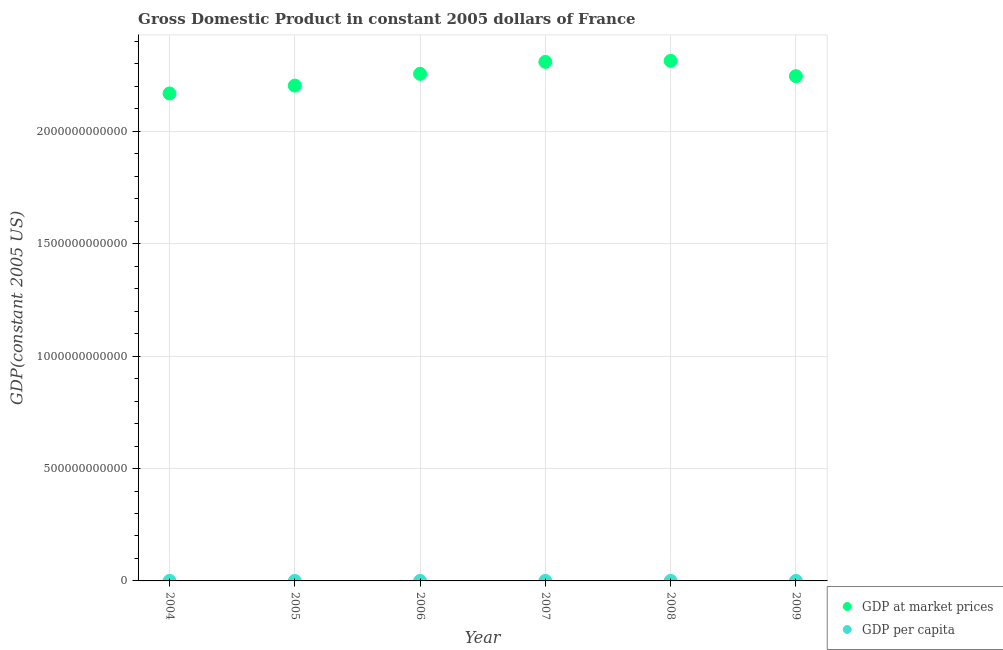What is the gdp per capita in 2008?
Your answer should be very brief. 3.59e+04. Across all years, what is the maximum gdp per capita?
Provide a short and direct response. 3.61e+04. Across all years, what is the minimum gdp per capita?
Provide a short and direct response. 3.46e+04. In which year was the gdp per capita minimum?
Your answer should be compact. 2004. What is the total gdp per capita in the graph?
Offer a terse response. 2.12e+05. What is the difference between the gdp per capita in 2007 and that in 2008?
Your answer should be very brief. 130.98. What is the difference between the gdp per capita in 2007 and the gdp at market prices in 2008?
Give a very brief answer. -2.31e+12. What is the average gdp at market prices per year?
Keep it short and to the point. 2.25e+12. In the year 2007, what is the difference between the gdp at market prices and gdp per capita?
Provide a succinct answer. 2.31e+12. What is the ratio of the gdp at market prices in 2004 to that in 2005?
Offer a terse response. 0.98. Is the difference between the gdp per capita in 2005 and 2009 greater than the difference between the gdp at market prices in 2005 and 2009?
Provide a succinct answer. Yes. What is the difference between the highest and the second highest gdp at market prices?
Offer a very short reply. 4.51e+09. What is the difference between the highest and the lowest gdp at market prices?
Make the answer very short. 1.45e+11. In how many years, is the gdp per capita greater than the average gdp per capita taken over all years?
Give a very brief answer. 3. How many years are there in the graph?
Your response must be concise. 6. What is the difference between two consecutive major ticks on the Y-axis?
Your response must be concise. 5.00e+11. Are the values on the major ticks of Y-axis written in scientific E-notation?
Make the answer very short. No. Does the graph contain grids?
Give a very brief answer. Yes. Where does the legend appear in the graph?
Your answer should be compact. Bottom right. How many legend labels are there?
Give a very brief answer. 2. How are the legend labels stacked?
Your response must be concise. Vertical. What is the title of the graph?
Ensure brevity in your answer.  Gross Domestic Product in constant 2005 dollars of France. What is the label or title of the Y-axis?
Offer a very short reply. GDP(constant 2005 US). What is the GDP(constant 2005 US) in GDP at market prices in 2004?
Give a very brief answer. 2.17e+12. What is the GDP(constant 2005 US) of GDP per capita in 2004?
Your response must be concise. 3.46e+04. What is the GDP(constant 2005 US) in GDP at market prices in 2005?
Offer a very short reply. 2.20e+12. What is the GDP(constant 2005 US) of GDP per capita in 2005?
Your answer should be very brief. 3.49e+04. What is the GDP(constant 2005 US) of GDP at market prices in 2006?
Your answer should be compact. 2.26e+12. What is the GDP(constant 2005 US) in GDP per capita in 2006?
Your answer should be compact. 3.55e+04. What is the GDP(constant 2005 US) of GDP at market prices in 2007?
Provide a succinct answer. 2.31e+12. What is the GDP(constant 2005 US) in GDP per capita in 2007?
Give a very brief answer. 3.61e+04. What is the GDP(constant 2005 US) in GDP at market prices in 2008?
Offer a very short reply. 2.31e+12. What is the GDP(constant 2005 US) of GDP per capita in 2008?
Ensure brevity in your answer.  3.59e+04. What is the GDP(constant 2005 US) of GDP at market prices in 2009?
Your answer should be compact. 2.25e+12. What is the GDP(constant 2005 US) in GDP per capita in 2009?
Make the answer very short. 3.47e+04. Across all years, what is the maximum GDP(constant 2005 US) in GDP at market prices?
Your answer should be very brief. 2.31e+12. Across all years, what is the maximum GDP(constant 2005 US) in GDP per capita?
Provide a short and direct response. 3.61e+04. Across all years, what is the minimum GDP(constant 2005 US) in GDP at market prices?
Make the answer very short. 2.17e+12. Across all years, what is the minimum GDP(constant 2005 US) in GDP per capita?
Ensure brevity in your answer.  3.46e+04. What is the total GDP(constant 2005 US) of GDP at market prices in the graph?
Give a very brief answer. 1.35e+13. What is the total GDP(constant 2005 US) of GDP per capita in the graph?
Keep it short and to the point. 2.12e+05. What is the difference between the GDP(constant 2005 US) of GDP at market prices in 2004 and that in 2005?
Your response must be concise. -3.49e+1. What is the difference between the GDP(constant 2005 US) of GDP per capita in 2004 and that in 2005?
Your answer should be compact. -292.15. What is the difference between the GDP(constant 2005 US) in GDP at market prices in 2004 and that in 2006?
Keep it short and to the point. -8.72e+1. What is the difference between the GDP(constant 2005 US) of GDP per capita in 2004 and that in 2006?
Your answer should be compact. -872.44. What is the difference between the GDP(constant 2005 US) of GDP at market prices in 2004 and that in 2007?
Provide a short and direct response. -1.40e+11. What is the difference between the GDP(constant 2005 US) of GDP per capita in 2004 and that in 2007?
Keep it short and to the point. -1485.94. What is the difference between the GDP(constant 2005 US) of GDP at market prices in 2004 and that in 2008?
Give a very brief answer. -1.45e+11. What is the difference between the GDP(constant 2005 US) of GDP per capita in 2004 and that in 2008?
Make the answer very short. -1354.96. What is the difference between the GDP(constant 2005 US) in GDP at market prices in 2004 and that in 2009?
Your answer should be very brief. -7.69e+1. What is the difference between the GDP(constant 2005 US) of GDP per capita in 2004 and that in 2009?
Offer a terse response. -118.75. What is the difference between the GDP(constant 2005 US) in GDP at market prices in 2005 and that in 2006?
Keep it short and to the point. -5.23e+1. What is the difference between the GDP(constant 2005 US) of GDP per capita in 2005 and that in 2006?
Your answer should be very brief. -580.29. What is the difference between the GDP(constant 2005 US) in GDP at market prices in 2005 and that in 2007?
Your answer should be very brief. -1.06e+11. What is the difference between the GDP(constant 2005 US) in GDP per capita in 2005 and that in 2007?
Provide a succinct answer. -1193.79. What is the difference between the GDP(constant 2005 US) of GDP at market prices in 2005 and that in 2008?
Provide a succinct answer. -1.10e+11. What is the difference between the GDP(constant 2005 US) in GDP per capita in 2005 and that in 2008?
Keep it short and to the point. -1062.81. What is the difference between the GDP(constant 2005 US) in GDP at market prices in 2005 and that in 2009?
Your answer should be very brief. -4.21e+1. What is the difference between the GDP(constant 2005 US) of GDP per capita in 2005 and that in 2009?
Provide a short and direct response. 173.4. What is the difference between the GDP(constant 2005 US) of GDP at market prices in 2006 and that in 2007?
Your answer should be compact. -5.33e+1. What is the difference between the GDP(constant 2005 US) of GDP per capita in 2006 and that in 2007?
Your response must be concise. -613.5. What is the difference between the GDP(constant 2005 US) in GDP at market prices in 2006 and that in 2008?
Give a very brief answer. -5.78e+1. What is the difference between the GDP(constant 2005 US) of GDP per capita in 2006 and that in 2008?
Your answer should be compact. -482.52. What is the difference between the GDP(constant 2005 US) in GDP at market prices in 2006 and that in 2009?
Offer a very short reply. 1.03e+1. What is the difference between the GDP(constant 2005 US) in GDP per capita in 2006 and that in 2009?
Offer a very short reply. 753.69. What is the difference between the GDP(constant 2005 US) of GDP at market prices in 2007 and that in 2008?
Offer a terse response. -4.51e+09. What is the difference between the GDP(constant 2005 US) in GDP per capita in 2007 and that in 2008?
Keep it short and to the point. 130.98. What is the difference between the GDP(constant 2005 US) of GDP at market prices in 2007 and that in 2009?
Keep it short and to the point. 6.35e+1. What is the difference between the GDP(constant 2005 US) in GDP per capita in 2007 and that in 2009?
Your answer should be very brief. 1367.19. What is the difference between the GDP(constant 2005 US) of GDP at market prices in 2008 and that in 2009?
Your response must be concise. 6.81e+1. What is the difference between the GDP(constant 2005 US) in GDP per capita in 2008 and that in 2009?
Give a very brief answer. 1236.21. What is the difference between the GDP(constant 2005 US) in GDP at market prices in 2004 and the GDP(constant 2005 US) in GDP per capita in 2005?
Your answer should be compact. 2.17e+12. What is the difference between the GDP(constant 2005 US) of GDP at market prices in 2004 and the GDP(constant 2005 US) of GDP per capita in 2006?
Your answer should be compact. 2.17e+12. What is the difference between the GDP(constant 2005 US) of GDP at market prices in 2004 and the GDP(constant 2005 US) of GDP per capita in 2007?
Your response must be concise. 2.17e+12. What is the difference between the GDP(constant 2005 US) of GDP at market prices in 2004 and the GDP(constant 2005 US) of GDP per capita in 2008?
Make the answer very short. 2.17e+12. What is the difference between the GDP(constant 2005 US) in GDP at market prices in 2004 and the GDP(constant 2005 US) in GDP per capita in 2009?
Give a very brief answer. 2.17e+12. What is the difference between the GDP(constant 2005 US) of GDP at market prices in 2005 and the GDP(constant 2005 US) of GDP per capita in 2006?
Keep it short and to the point. 2.20e+12. What is the difference between the GDP(constant 2005 US) of GDP at market prices in 2005 and the GDP(constant 2005 US) of GDP per capita in 2007?
Your response must be concise. 2.20e+12. What is the difference between the GDP(constant 2005 US) in GDP at market prices in 2005 and the GDP(constant 2005 US) in GDP per capita in 2008?
Keep it short and to the point. 2.20e+12. What is the difference between the GDP(constant 2005 US) in GDP at market prices in 2005 and the GDP(constant 2005 US) in GDP per capita in 2009?
Keep it short and to the point. 2.20e+12. What is the difference between the GDP(constant 2005 US) in GDP at market prices in 2006 and the GDP(constant 2005 US) in GDP per capita in 2007?
Your response must be concise. 2.26e+12. What is the difference between the GDP(constant 2005 US) of GDP at market prices in 2006 and the GDP(constant 2005 US) of GDP per capita in 2008?
Keep it short and to the point. 2.26e+12. What is the difference between the GDP(constant 2005 US) of GDP at market prices in 2006 and the GDP(constant 2005 US) of GDP per capita in 2009?
Your response must be concise. 2.26e+12. What is the difference between the GDP(constant 2005 US) in GDP at market prices in 2007 and the GDP(constant 2005 US) in GDP per capita in 2008?
Your answer should be very brief. 2.31e+12. What is the difference between the GDP(constant 2005 US) in GDP at market prices in 2007 and the GDP(constant 2005 US) in GDP per capita in 2009?
Make the answer very short. 2.31e+12. What is the difference between the GDP(constant 2005 US) in GDP at market prices in 2008 and the GDP(constant 2005 US) in GDP per capita in 2009?
Ensure brevity in your answer.  2.31e+12. What is the average GDP(constant 2005 US) of GDP at market prices per year?
Your answer should be very brief. 2.25e+12. What is the average GDP(constant 2005 US) in GDP per capita per year?
Your response must be concise. 3.53e+04. In the year 2004, what is the difference between the GDP(constant 2005 US) in GDP at market prices and GDP(constant 2005 US) in GDP per capita?
Your response must be concise. 2.17e+12. In the year 2005, what is the difference between the GDP(constant 2005 US) of GDP at market prices and GDP(constant 2005 US) of GDP per capita?
Provide a succinct answer. 2.20e+12. In the year 2006, what is the difference between the GDP(constant 2005 US) of GDP at market prices and GDP(constant 2005 US) of GDP per capita?
Keep it short and to the point. 2.26e+12. In the year 2007, what is the difference between the GDP(constant 2005 US) of GDP at market prices and GDP(constant 2005 US) of GDP per capita?
Provide a short and direct response. 2.31e+12. In the year 2008, what is the difference between the GDP(constant 2005 US) in GDP at market prices and GDP(constant 2005 US) in GDP per capita?
Provide a succinct answer. 2.31e+12. In the year 2009, what is the difference between the GDP(constant 2005 US) of GDP at market prices and GDP(constant 2005 US) of GDP per capita?
Provide a succinct answer. 2.25e+12. What is the ratio of the GDP(constant 2005 US) in GDP at market prices in 2004 to that in 2005?
Offer a very short reply. 0.98. What is the ratio of the GDP(constant 2005 US) of GDP at market prices in 2004 to that in 2006?
Your answer should be compact. 0.96. What is the ratio of the GDP(constant 2005 US) of GDP per capita in 2004 to that in 2006?
Offer a terse response. 0.98. What is the ratio of the GDP(constant 2005 US) in GDP at market prices in 2004 to that in 2007?
Offer a very short reply. 0.94. What is the ratio of the GDP(constant 2005 US) of GDP per capita in 2004 to that in 2007?
Offer a terse response. 0.96. What is the ratio of the GDP(constant 2005 US) in GDP at market prices in 2004 to that in 2008?
Provide a short and direct response. 0.94. What is the ratio of the GDP(constant 2005 US) of GDP per capita in 2004 to that in 2008?
Keep it short and to the point. 0.96. What is the ratio of the GDP(constant 2005 US) of GDP at market prices in 2004 to that in 2009?
Give a very brief answer. 0.97. What is the ratio of the GDP(constant 2005 US) of GDP per capita in 2004 to that in 2009?
Offer a very short reply. 1. What is the ratio of the GDP(constant 2005 US) in GDP at market prices in 2005 to that in 2006?
Your answer should be compact. 0.98. What is the ratio of the GDP(constant 2005 US) in GDP per capita in 2005 to that in 2006?
Provide a short and direct response. 0.98. What is the ratio of the GDP(constant 2005 US) in GDP at market prices in 2005 to that in 2007?
Keep it short and to the point. 0.95. What is the ratio of the GDP(constant 2005 US) in GDP per capita in 2005 to that in 2007?
Your answer should be very brief. 0.97. What is the ratio of the GDP(constant 2005 US) in GDP at market prices in 2005 to that in 2008?
Ensure brevity in your answer.  0.95. What is the ratio of the GDP(constant 2005 US) in GDP per capita in 2005 to that in 2008?
Offer a terse response. 0.97. What is the ratio of the GDP(constant 2005 US) of GDP at market prices in 2005 to that in 2009?
Make the answer very short. 0.98. What is the ratio of the GDP(constant 2005 US) of GDP at market prices in 2006 to that in 2007?
Keep it short and to the point. 0.98. What is the ratio of the GDP(constant 2005 US) in GDP at market prices in 2006 to that in 2008?
Provide a succinct answer. 0.97. What is the ratio of the GDP(constant 2005 US) of GDP per capita in 2006 to that in 2008?
Offer a terse response. 0.99. What is the ratio of the GDP(constant 2005 US) in GDP per capita in 2006 to that in 2009?
Ensure brevity in your answer.  1.02. What is the ratio of the GDP(constant 2005 US) of GDP at market prices in 2007 to that in 2008?
Ensure brevity in your answer.  1. What is the ratio of the GDP(constant 2005 US) in GDP at market prices in 2007 to that in 2009?
Ensure brevity in your answer.  1.03. What is the ratio of the GDP(constant 2005 US) of GDP per capita in 2007 to that in 2009?
Give a very brief answer. 1.04. What is the ratio of the GDP(constant 2005 US) in GDP at market prices in 2008 to that in 2009?
Offer a terse response. 1.03. What is the ratio of the GDP(constant 2005 US) in GDP per capita in 2008 to that in 2009?
Give a very brief answer. 1.04. What is the difference between the highest and the second highest GDP(constant 2005 US) of GDP at market prices?
Your answer should be very brief. 4.51e+09. What is the difference between the highest and the second highest GDP(constant 2005 US) in GDP per capita?
Keep it short and to the point. 130.98. What is the difference between the highest and the lowest GDP(constant 2005 US) of GDP at market prices?
Provide a succinct answer. 1.45e+11. What is the difference between the highest and the lowest GDP(constant 2005 US) of GDP per capita?
Keep it short and to the point. 1485.94. 